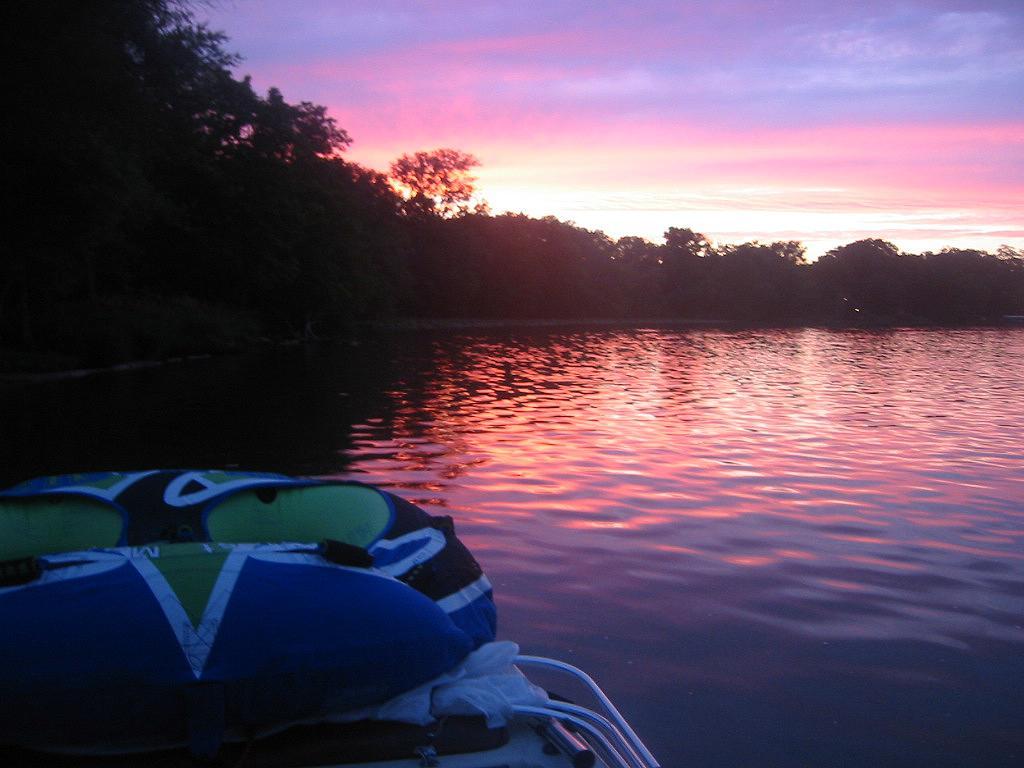Could you give a brief overview of what you see in this image? On the left side it is the boat,this is water. There are trees in the middle, at the top it is the sky. 